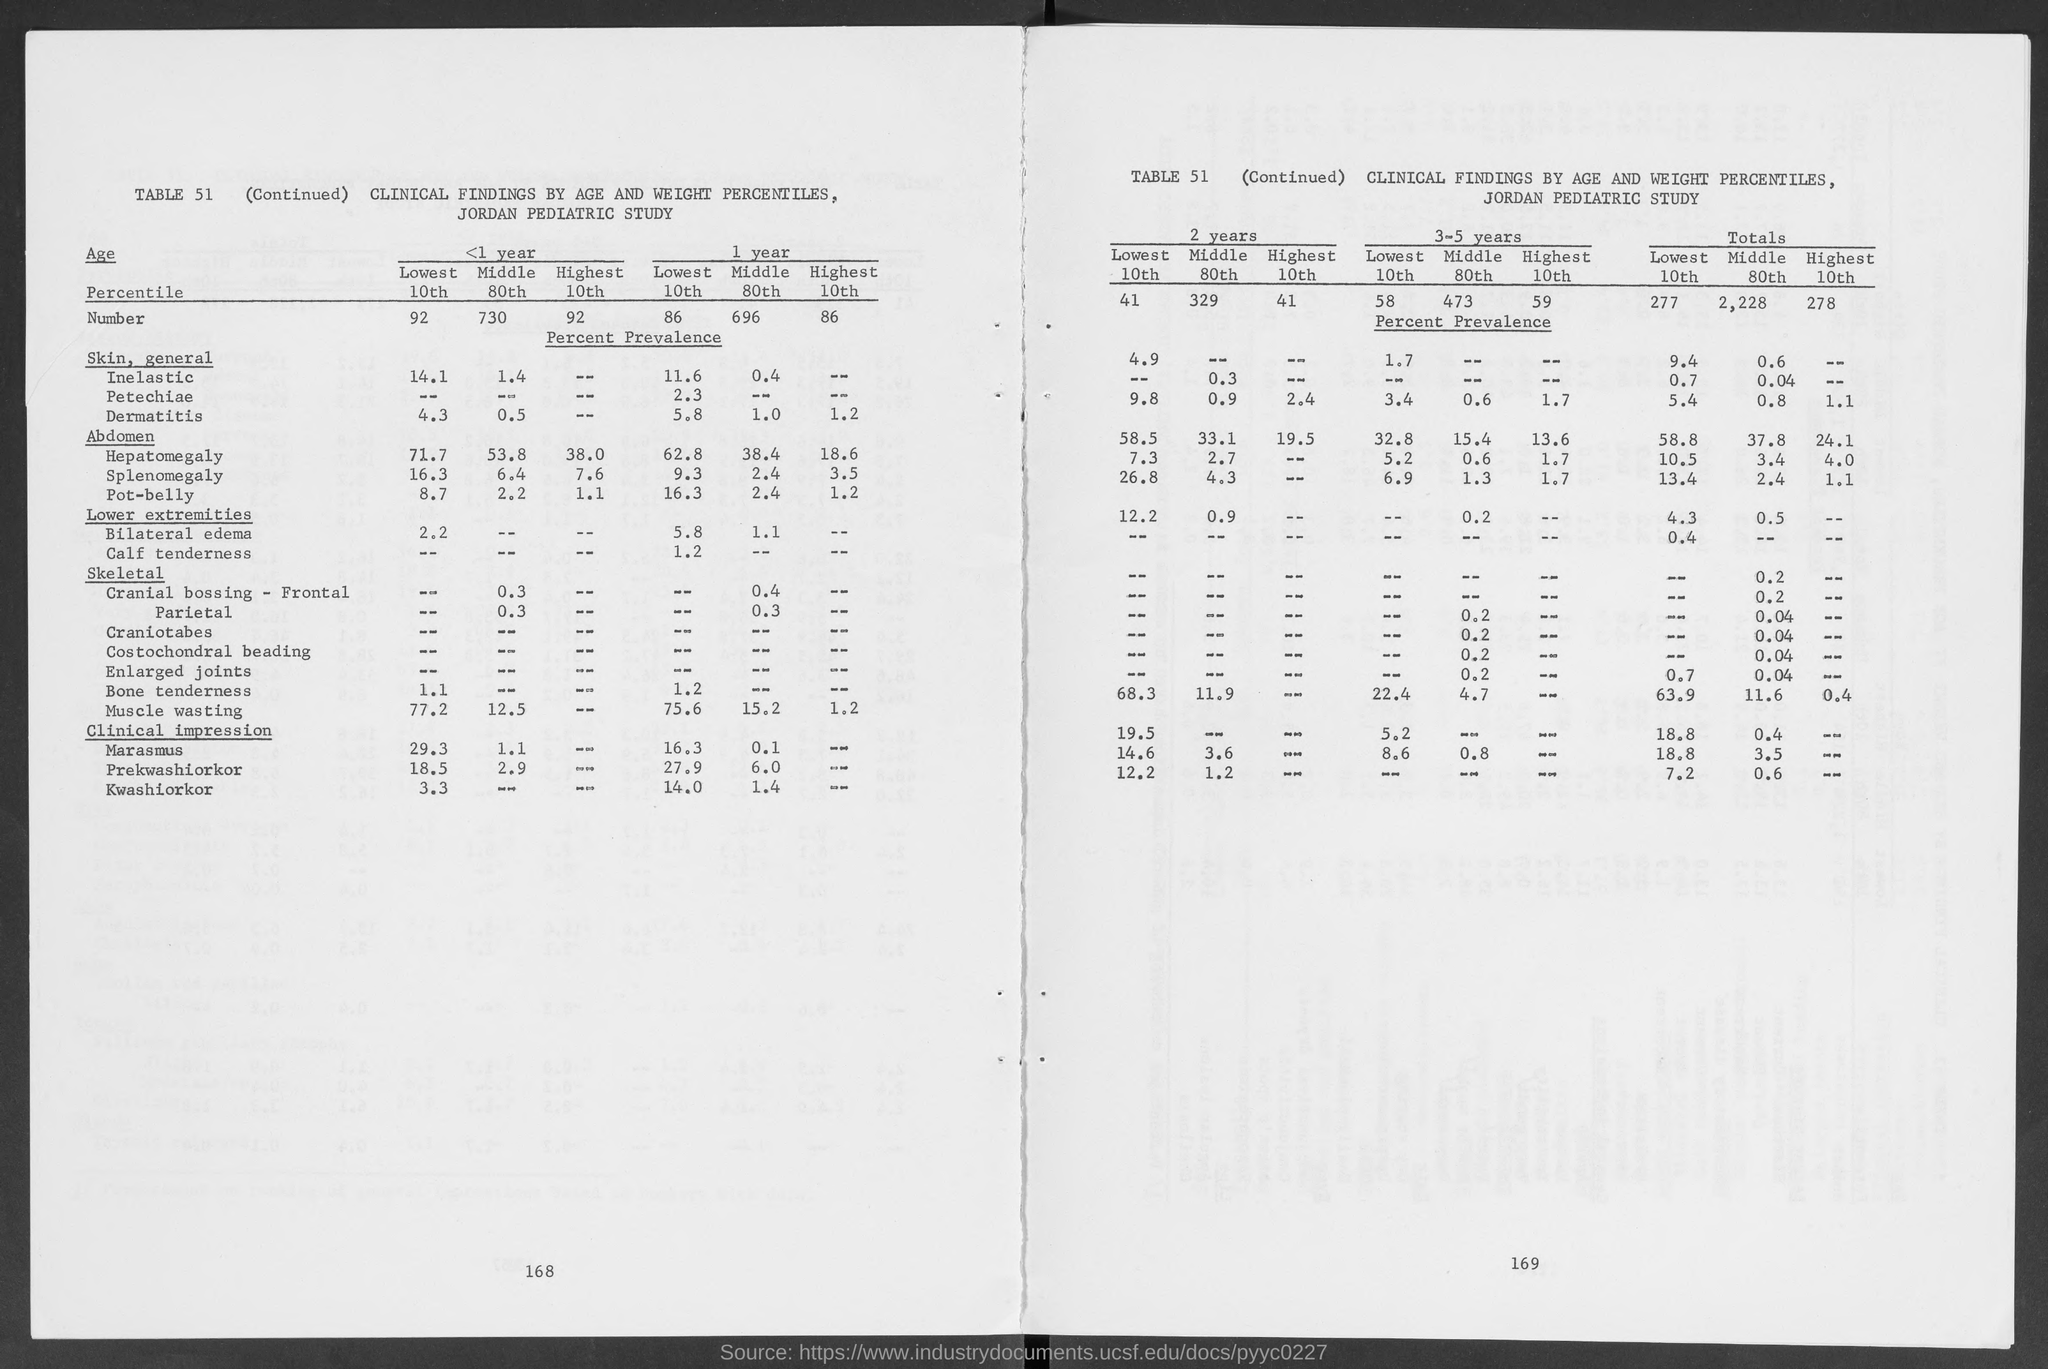What is the table number?
Your answer should be compact. 51. What is the total number of "lowest 10th"?
Make the answer very short. 277. What is the total number of "middle 80th"?
Give a very brief answer. 2,228. What is the total number of "highest 10th"?
Provide a succinct answer. 278. What is the number of "lowest 10th" in the first year?
Keep it short and to the point. 86. What is the number of "middle 80th" in the first year?
Offer a very short reply. 696. What is the number of "highest 10th" in the first year?
Ensure brevity in your answer.  86. 